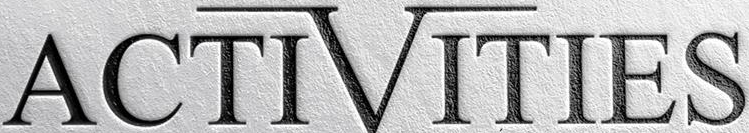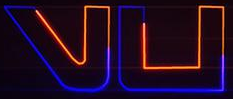Read the text from these images in sequence, separated by a semicolon. ACTIVITIES; vu 